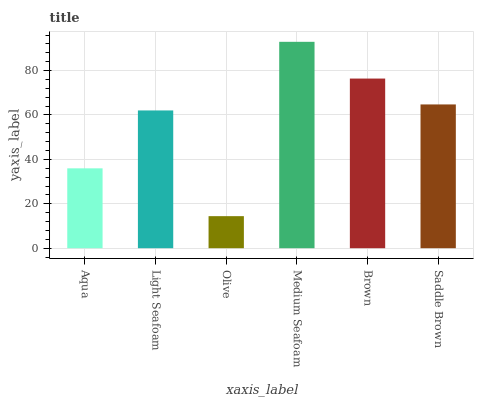Is Olive the minimum?
Answer yes or no. Yes. Is Medium Seafoam the maximum?
Answer yes or no. Yes. Is Light Seafoam the minimum?
Answer yes or no. No. Is Light Seafoam the maximum?
Answer yes or no. No. Is Light Seafoam greater than Aqua?
Answer yes or no. Yes. Is Aqua less than Light Seafoam?
Answer yes or no. Yes. Is Aqua greater than Light Seafoam?
Answer yes or no. No. Is Light Seafoam less than Aqua?
Answer yes or no. No. Is Saddle Brown the high median?
Answer yes or no. Yes. Is Light Seafoam the low median?
Answer yes or no. Yes. Is Light Seafoam the high median?
Answer yes or no. No. Is Brown the low median?
Answer yes or no. No. 